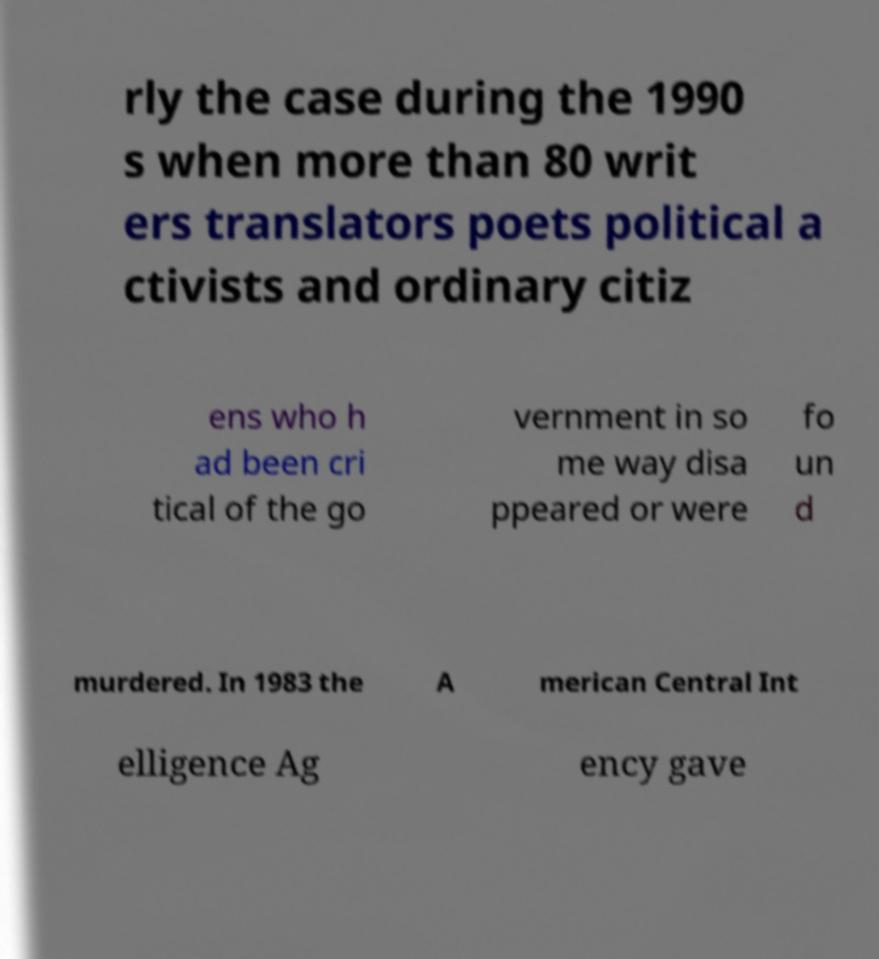Can you read and provide the text displayed in the image?This photo seems to have some interesting text. Can you extract and type it out for me? rly the case during the 1990 s when more than 80 writ ers translators poets political a ctivists and ordinary citiz ens who h ad been cri tical of the go vernment in so me way disa ppeared or were fo un d murdered. In 1983 the A merican Central Int elligence Ag ency gave 